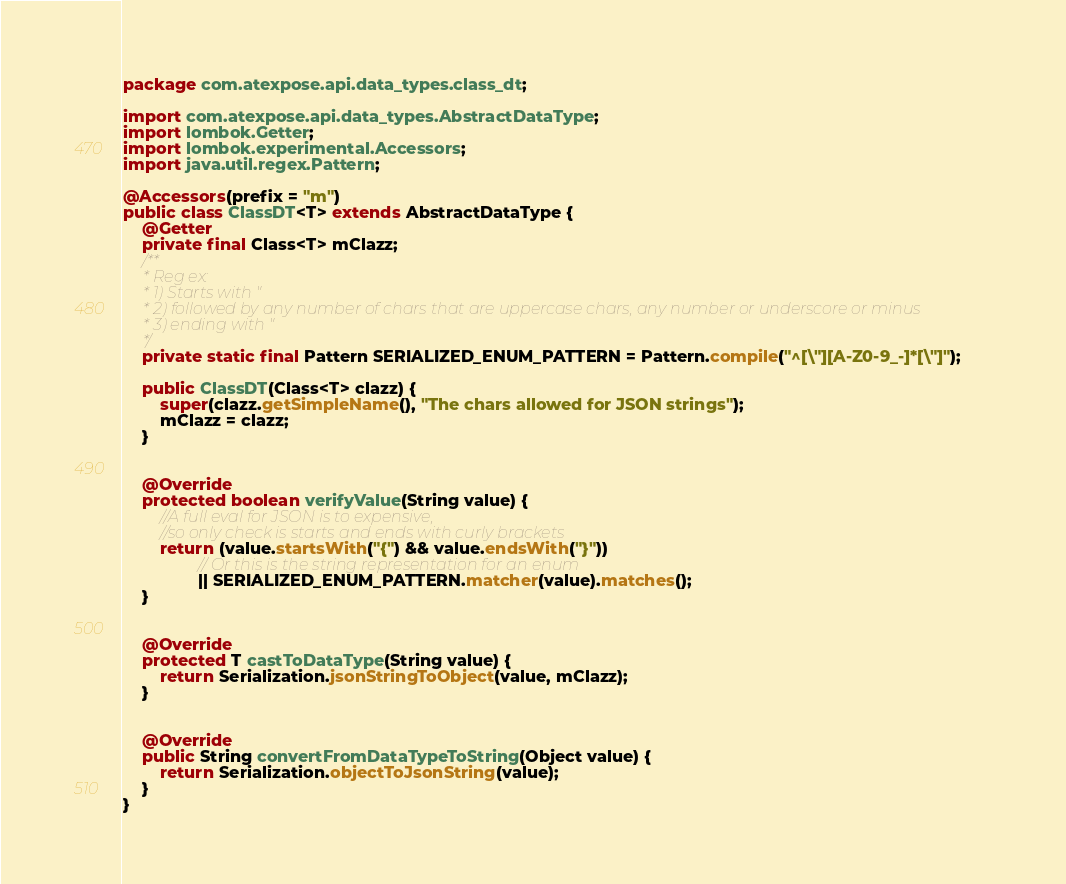<code> <loc_0><loc_0><loc_500><loc_500><_Java_>package com.atexpose.api.data_types.class_dt;

import com.atexpose.api.data_types.AbstractDataType;
import lombok.Getter;
import lombok.experimental.Accessors;
import java.util.regex.Pattern;

@Accessors(prefix = "m")
public class ClassDT<T> extends AbstractDataType {
    @Getter
    private final Class<T> mClazz;
    /**
     * Reg ex:
     * 1) Starts with "
     * 2) followed by any number of chars that are uppercase chars, any number or underscore or minus
     * 3) ending with "
     */
    private static final Pattern SERIALIZED_ENUM_PATTERN = Pattern.compile("^[\"][A-Z0-9_-]*[\"]");

    public ClassDT(Class<T> clazz) {
        super(clazz.getSimpleName(), "The chars allowed for JSON strings");
        mClazz = clazz;
    }


    @Override
    protected boolean verifyValue(String value) {
        //A full eval for JSON is to expensive,
        //so only check is starts and ends with curly brackets
        return (value.startsWith("{") && value.endsWith("}"))
                // Or this is the string representation for an enum
                || SERIALIZED_ENUM_PATTERN.matcher(value).matches();
    }


    @Override
    protected T castToDataType(String value) {
        return Serialization.jsonStringToObject(value, mClazz);
    }


    @Override
    public String convertFromDataTypeToString(Object value) {
        return Serialization.objectToJsonString(value);
    }
}</code> 